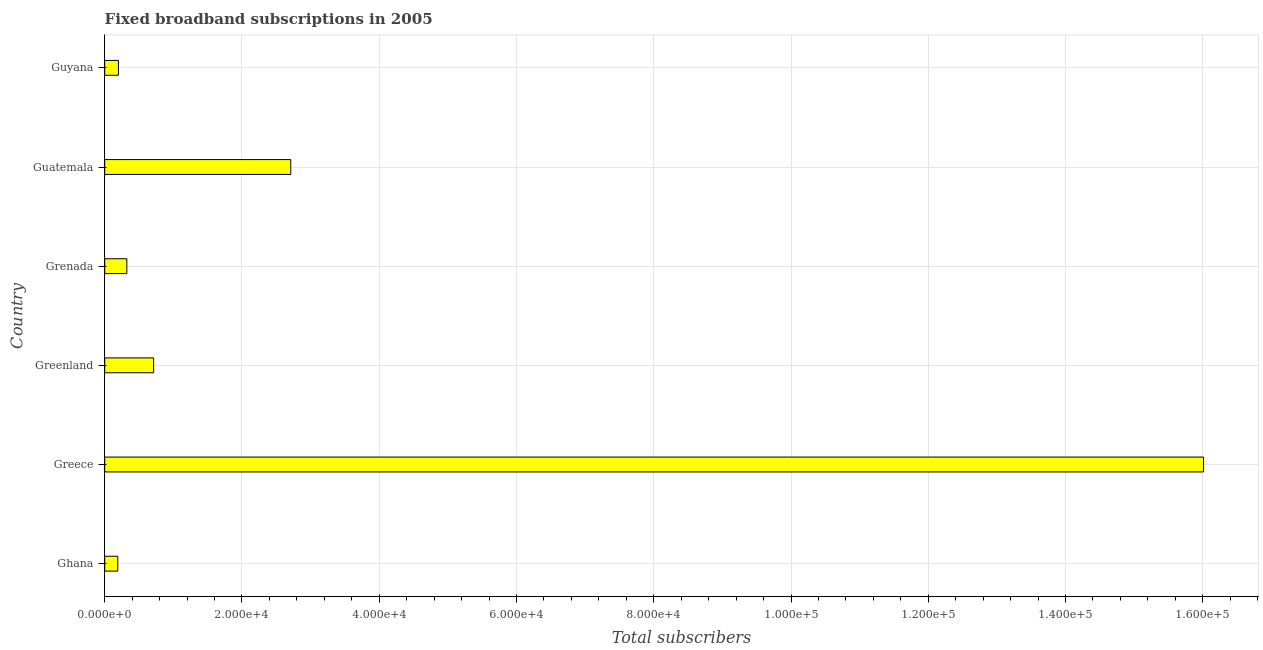Does the graph contain any zero values?
Keep it short and to the point. No. Does the graph contain grids?
Your response must be concise. Yes. What is the title of the graph?
Ensure brevity in your answer.  Fixed broadband subscriptions in 2005. What is the label or title of the X-axis?
Keep it short and to the point. Total subscribers. What is the label or title of the Y-axis?
Ensure brevity in your answer.  Country. What is the total number of fixed broadband subscriptions in Greece?
Keep it short and to the point. 1.60e+05. Across all countries, what is the maximum total number of fixed broadband subscriptions?
Keep it short and to the point. 1.60e+05. Across all countries, what is the minimum total number of fixed broadband subscriptions?
Make the answer very short. 1904. In which country was the total number of fixed broadband subscriptions minimum?
Your answer should be very brief. Ghana. What is the sum of the total number of fixed broadband subscriptions?
Keep it short and to the point. 2.01e+05. What is the difference between the total number of fixed broadband subscriptions in Greece and Guyana?
Offer a terse response. 1.58e+05. What is the average total number of fixed broadband subscriptions per country?
Your answer should be compact. 3.36e+04. What is the median total number of fixed broadband subscriptions?
Ensure brevity in your answer.  5175. In how many countries, is the total number of fixed broadband subscriptions greater than 96000 ?
Provide a succinct answer. 1. What is the ratio of the total number of fixed broadband subscriptions in Greece to that in Guatemala?
Give a very brief answer. 5.91. What is the difference between the highest and the second highest total number of fixed broadband subscriptions?
Give a very brief answer. 1.33e+05. Is the sum of the total number of fixed broadband subscriptions in Greece and Guatemala greater than the maximum total number of fixed broadband subscriptions across all countries?
Provide a succinct answer. Yes. What is the difference between the highest and the lowest total number of fixed broadband subscriptions?
Offer a terse response. 1.58e+05. In how many countries, is the total number of fixed broadband subscriptions greater than the average total number of fixed broadband subscriptions taken over all countries?
Your answer should be compact. 1. How many bars are there?
Make the answer very short. 6. What is the difference between two consecutive major ticks on the X-axis?
Give a very brief answer. 2.00e+04. Are the values on the major ticks of X-axis written in scientific E-notation?
Offer a terse response. Yes. What is the Total subscribers of Ghana?
Your response must be concise. 1904. What is the Total subscribers of Greece?
Keep it short and to the point. 1.60e+05. What is the Total subscribers in Greenland?
Make the answer very short. 7128. What is the Total subscribers in Grenada?
Your response must be concise. 3222. What is the Total subscribers in Guatemala?
Offer a very short reply. 2.71e+04. What is the difference between the Total subscribers in Ghana and Greece?
Make the answer very short. -1.58e+05. What is the difference between the Total subscribers in Ghana and Greenland?
Keep it short and to the point. -5224. What is the difference between the Total subscribers in Ghana and Grenada?
Your response must be concise. -1318. What is the difference between the Total subscribers in Ghana and Guatemala?
Your answer should be compact. -2.52e+04. What is the difference between the Total subscribers in Ghana and Guyana?
Offer a very short reply. -96. What is the difference between the Total subscribers in Greece and Greenland?
Give a very brief answer. 1.53e+05. What is the difference between the Total subscribers in Greece and Grenada?
Ensure brevity in your answer.  1.57e+05. What is the difference between the Total subscribers in Greece and Guatemala?
Offer a terse response. 1.33e+05. What is the difference between the Total subscribers in Greece and Guyana?
Provide a short and direct response. 1.58e+05. What is the difference between the Total subscribers in Greenland and Grenada?
Provide a short and direct response. 3906. What is the difference between the Total subscribers in Greenland and Guatemala?
Provide a succinct answer. -2.00e+04. What is the difference between the Total subscribers in Greenland and Guyana?
Your answer should be compact. 5128. What is the difference between the Total subscribers in Grenada and Guatemala?
Provide a short and direct response. -2.39e+04. What is the difference between the Total subscribers in Grenada and Guyana?
Keep it short and to the point. 1222. What is the difference between the Total subscribers in Guatemala and Guyana?
Ensure brevity in your answer.  2.51e+04. What is the ratio of the Total subscribers in Ghana to that in Greece?
Provide a succinct answer. 0.01. What is the ratio of the Total subscribers in Ghana to that in Greenland?
Provide a succinct answer. 0.27. What is the ratio of the Total subscribers in Ghana to that in Grenada?
Provide a succinct answer. 0.59. What is the ratio of the Total subscribers in Ghana to that in Guatemala?
Your answer should be compact. 0.07. What is the ratio of the Total subscribers in Ghana to that in Guyana?
Provide a succinct answer. 0.95. What is the ratio of the Total subscribers in Greece to that in Greenland?
Your response must be concise. 22.46. What is the ratio of the Total subscribers in Greece to that in Grenada?
Your answer should be very brief. 49.69. What is the ratio of the Total subscribers in Greece to that in Guatemala?
Make the answer very short. 5.91. What is the ratio of the Total subscribers in Greece to that in Guyana?
Offer a very short reply. 80.06. What is the ratio of the Total subscribers in Greenland to that in Grenada?
Provide a succinct answer. 2.21. What is the ratio of the Total subscribers in Greenland to that in Guatemala?
Offer a terse response. 0.26. What is the ratio of the Total subscribers in Greenland to that in Guyana?
Provide a succinct answer. 3.56. What is the ratio of the Total subscribers in Grenada to that in Guatemala?
Ensure brevity in your answer.  0.12. What is the ratio of the Total subscribers in Grenada to that in Guyana?
Offer a terse response. 1.61. What is the ratio of the Total subscribers in Guatemala to that in Guyana?
Keep it short and to the point. 13.55. 